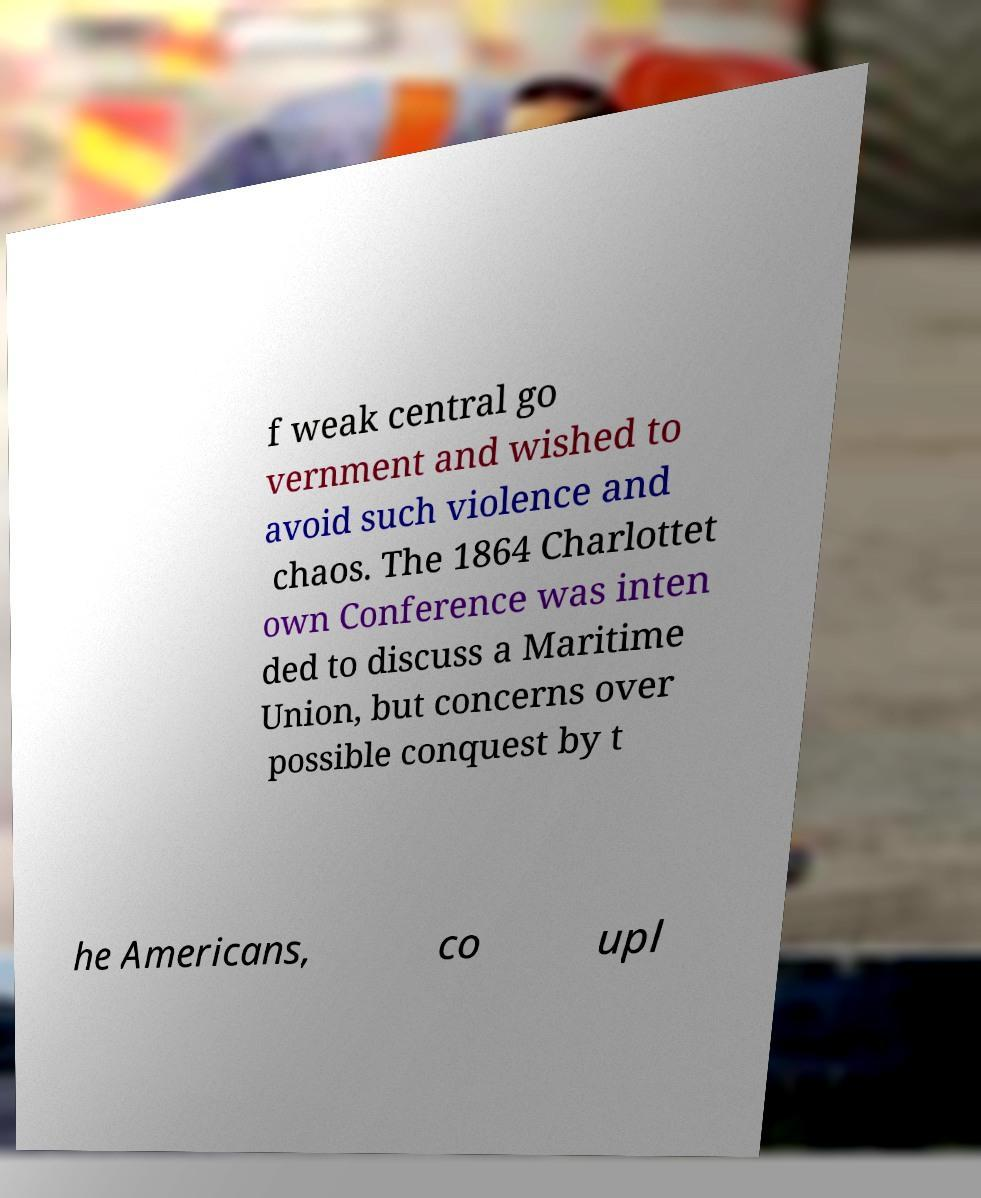There's text embedded in this image that I need extracted. Can you transcribe it verbatim? f weak central go vernment and wished to avoid such violence and chaos. The 1864 Charlottet own Conference was inten ded to discuss a Maritime Union, but concerns over possible conquest by t he Americans, co upl 